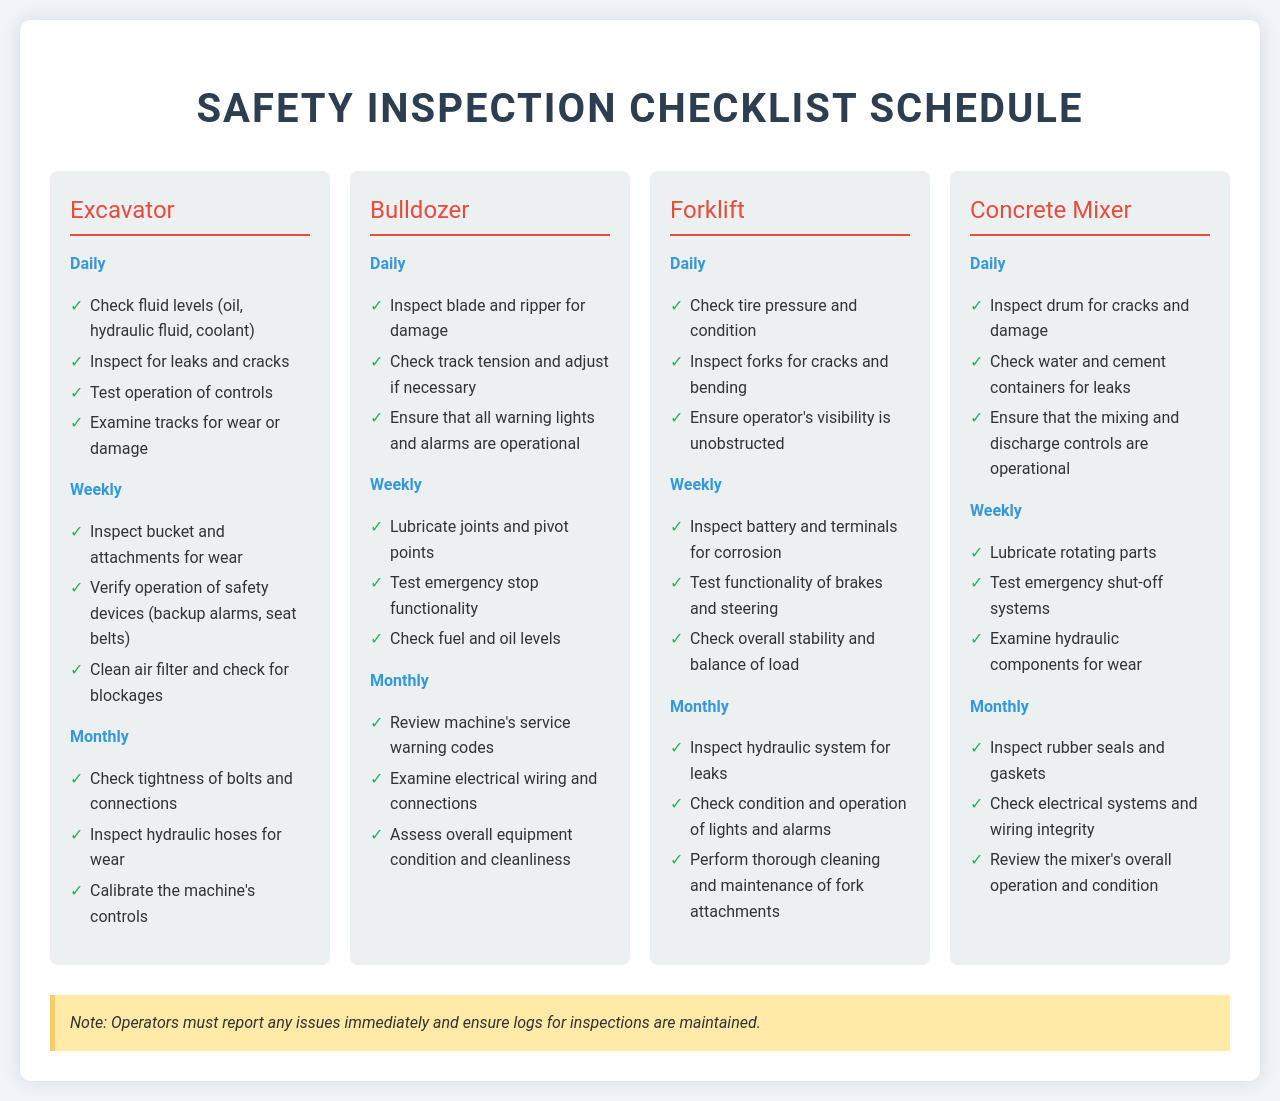What is the safety inspection frequency for the Excavator? The frequency for the Excavator is listed as Daily, Weekly, and Monthly in the document.
Answer: Daily, Weekly, Monthly How many items must be checked daily for the Bulldozer? The daily checks for the Bulldozer are detailed, totaling three items in the document.
Answer: 3 What is the first item on the daily checklist for Forklift? The Forklift's daily checklist begins with checking tire pressure and condition.
Answer: Check tire pressure and condition Which equipment type has the least number of items to check monthly? By comparing monthly checklists, the Forklift has three items to check, similar to others but is a simpler list, making it potentially the least complex.
Answer: Forklift What is one of the weekly inspection tasks for the Concrete Mixer? The document lists several weekly inspection tasks, one of which is to lubricate rotating parts.
Answer: Lubricate rotating parts How many monthly checks are outlined for the Excavator? The document specifies three monthly checks for the Excavator, categorized under the Monthly frequency.
Answer: 3 What color are the inspection titles for the frequency categories? The frequency titles in the document are styled with a blue color for clarity.
Answer: Blue Is there a note at the bottom of the inspection checklist? The document includes a note at the bottom which emphasizes immediate reporting of issues by operators.
Answer: Yes 